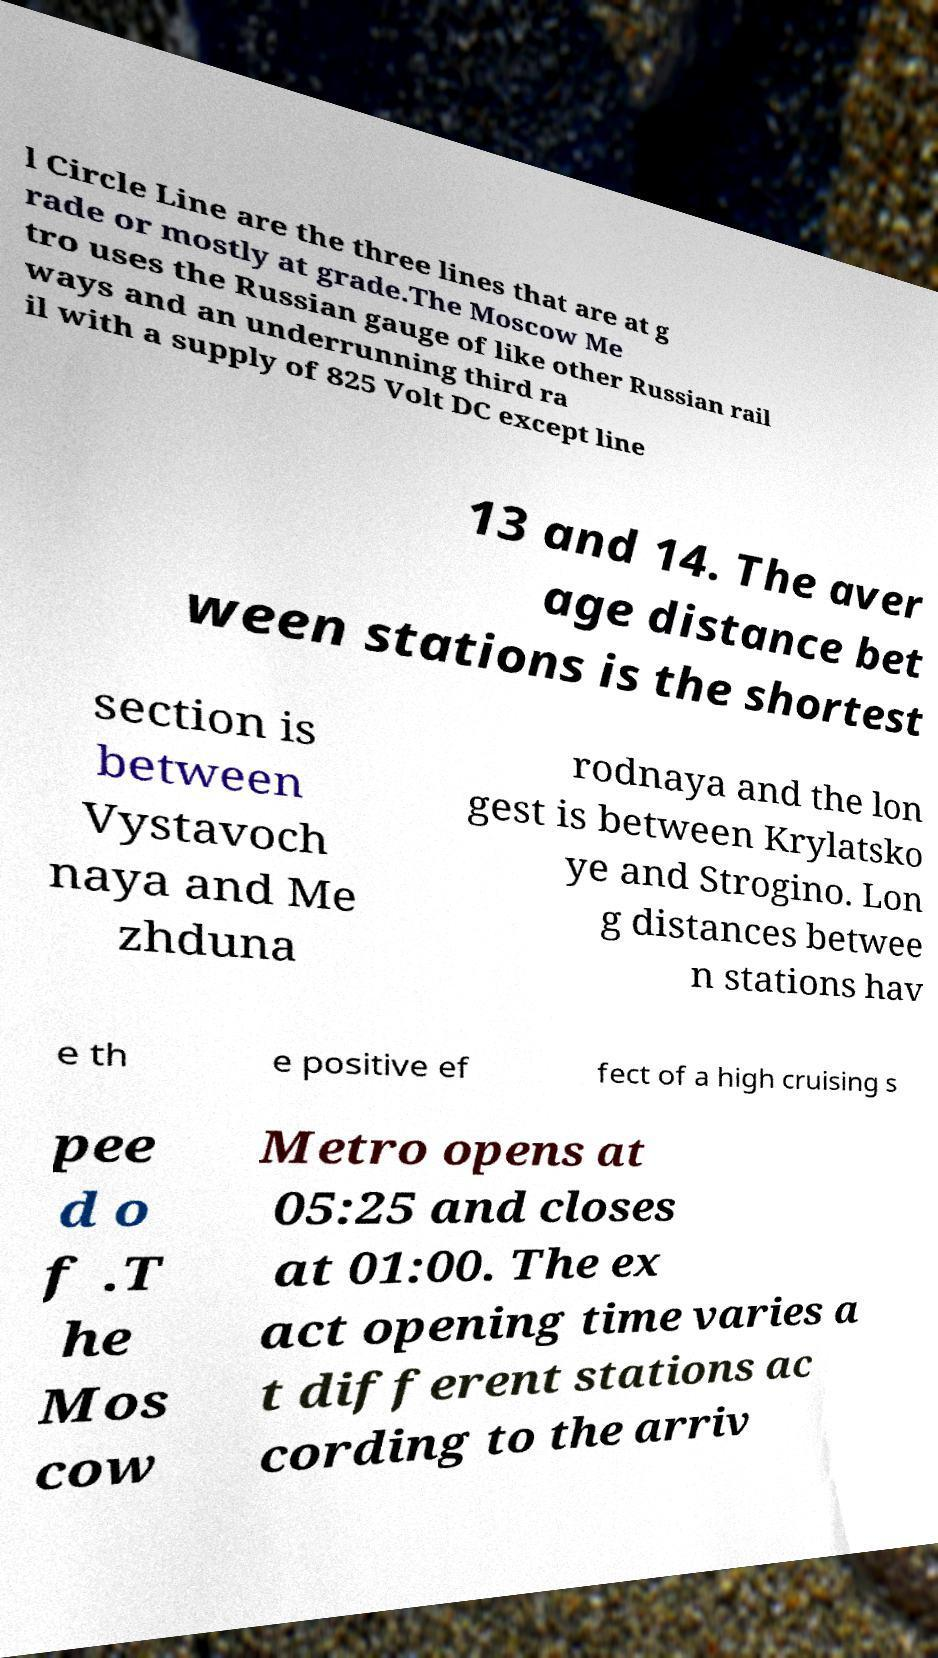I need the written content from this picture converted into text. Can you do that? l Circle Line are the three lines that are at g rade or mostly at grade.The Moscow Me tro uses the Russian gauge of like other Russian rail ways and an underrunning third ra il with a supply of 825 Volt DC except line 13 and 14. The aver age distance bet ween stations is the shortest section is between Vystavoch naya and Me zhduna rodnaya and the lon gest is between Krylatsko ye and Strogino. Lon g distances betwee n stations hav e th e positive ef fect of a high cruising s pee d o f .T he Mos cow Metro opens at 05:25 and closes at 01:00. The ex act opening time varies a t different stations ac cording to the arriv 